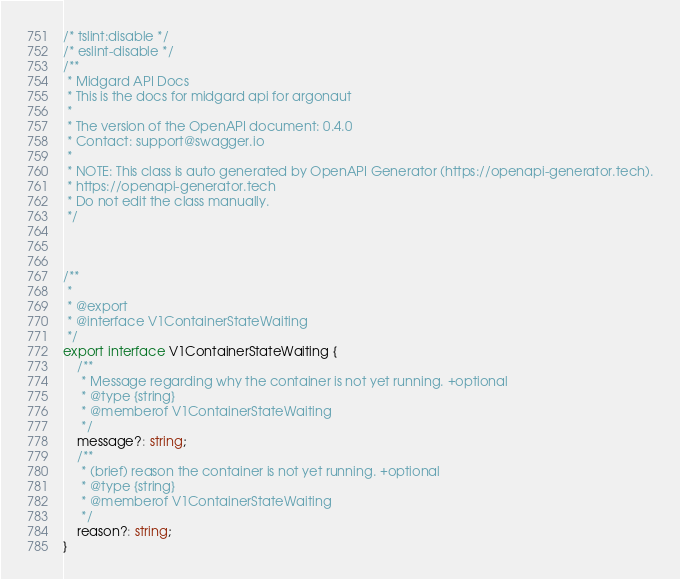<code> <loc_0><loc_0><loc_500><loc_500><_TypeScript_>/* tslint:disable */
/* eslint-disable */
/**
 * Midgard API Docs
 * This is the docs for midgard api for argonaut
 *
 * The version of the OpenAPI document: 0.4.0
 * Contact: support@swagger.io
 *
 * NOTE: This class is auto generated by OpenAPI Generator (https://openapi-generator.tech).
 * https://openapi-generator.tech
 * Do not edit the class manually.
 */



/**
 * 
 * @export
 * @interface V1ContainerStateWaiting
 */
export interface V1ContainerStateWaiting {
    /**
     * Message regarding why the container is not yet running. +optional
     * @type {string}
     * @memberof V1ContainerStateWaiting
     */
    message?: string;
    /**
     * (brief) reason the container is not yet running. +optional
     * @type {string}
     * @memberof V1ContainerStateWaiting
     */
    reason?: string;
}


</code> 